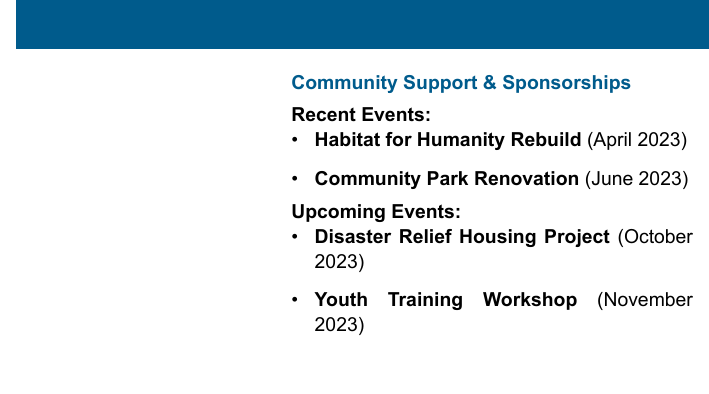what is the name of the executive director? The document states the name of the executive director as John Doe.
Answer: John Doe what is the email address provided? The email address listed in the document is johndoe@buildbright.com.
Answer: johndoe@buildbright.com when did the Habitat for Humanity Rebuild event take place? The document indicates that the Habitat for Humanity Rebuild event occurred in April 2023.
Answer: April 2023 how many upcoming events are listed? The document includes a total of two upcoming events under the Upcoming Events section.
Answer: 2 what is the phone number for John Doe? The phone number for John Doe provided in the document is +1-555-555-5555.
Answer: +1-555-555-5555 which event is scheduled for October 2023? According to the document, the Disaster Relief Housing Project is the event planned for October 2023.
Answer: Disaster Relief Housing Project what organization does John Doe represent? The document states that John Doe represents BuildBright Construction.
Answer: BuildBright Construction what color is used for the text highlighting community support? The document uses the color blue for the text highlighting community support.
Answer: Blue what type of document is this? This document is a business card that showcases contact information and community engagement details.
Answer: Business card 